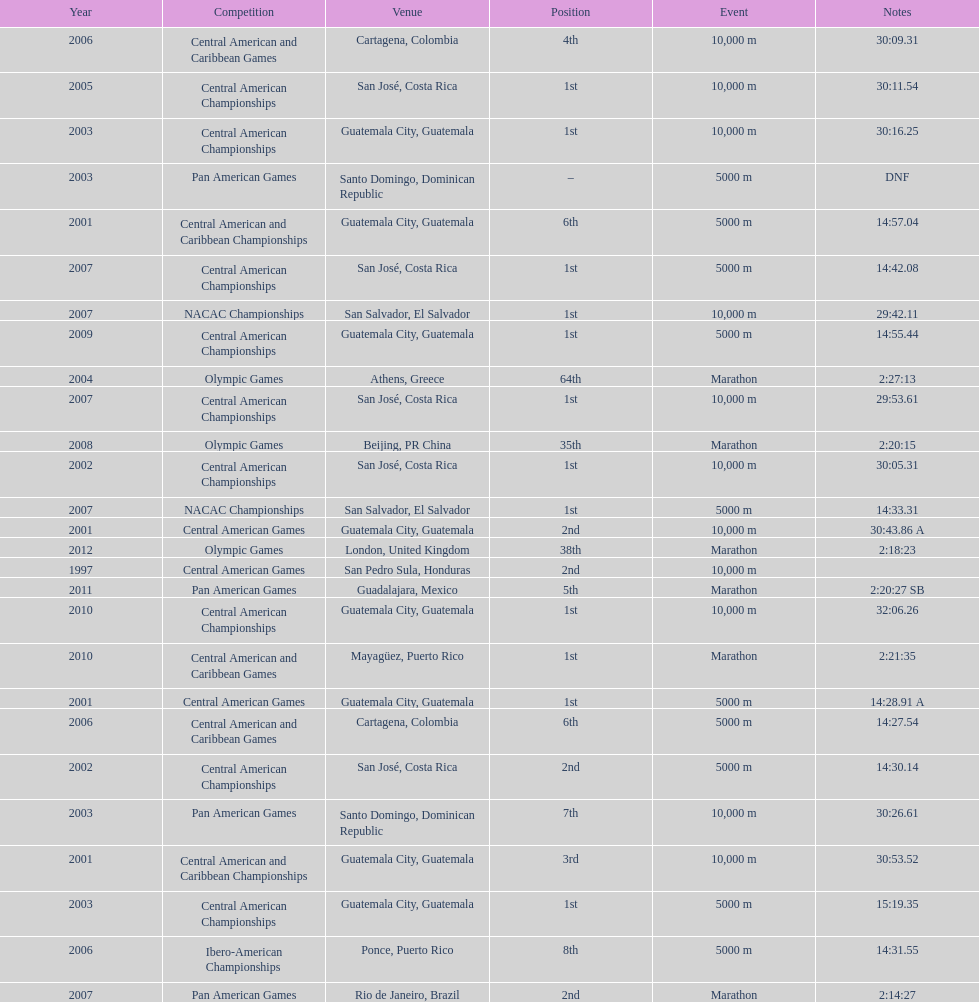Help me parse the entirety of this table. {'header': ['Year', 'Competition', 'Venue', 'Position', 'Event', 'Notes'], 'rows': [['2006', 'Central American and Caribbean Games', 'Cartagena, Colombia', '4th', '10,000 m', '30:09.31'], ['2005', 'Central American Championships', 'San José, Costa Rica', '1st', '10,000 m', '30:11.54'], ['2003', 'Central American Championships', 'Guatemala City, Guatemala', '1st', '10,000 m', '30:16.25'], ['2003', 'Pan American Games', 'Santo Domingo, Dominican Republic', '–', '5000 m', 'DNF'], ['2001', 'Central American and Caribbean Championships', 'Guatemala City, Guatemala', '6th', '5000 m', '14:57.04'], ['2007', 'Central American Championships', 'San José, Costa Rica', '1st', '5000 m', '14:42.08'], ['2007', 'NACAC Championships', 'San Salvador, El Salvador', '1st', '10,000 m', '29:42.11'], ['2009', 'Central American Championships', 'Guatemala City, Guatemala', '1st', '5000 m', '14:55.44'], ['2004', 'Olympic Games', 'Athens, Greece', '64th', 'Marathon', '2:27:13'], ['2007', 'Central American Championships', 'San José, Costa Rica', '1st', '10,000 m', '29:53.61'], ['2008', 'Olympic Games', 'Beijing, PR China', '35th', 'Marathon', '2:20:15'], ['2002', 'Central American Championships', 'San José, Costa Rica', '1st', '10,000 m', '30:05.31'], ['2007', 'NACAC Championships', 'San Salvador, El Salvador', '1st', '5000 m', '14:33.31'], ['2001', 'Central American Games', 'Guatemala City, Guatemala', '2nd', '10,000 m', '30:43.86 A'], ['2012', 'Olympic Games', 'London, United Kingdom', '38th', 'Marathon', '2:18:23'], ['1997', 'Central American Games', 'San Pedro Sula, Honduras', '2nd', '10,000 m', ''], ['2011', 'Pan American Games', 'Guadalajara, Mexico', '5th', 'Marathon', '2:20:27 SB'], ['2010', 'Central American Championships', 'Guatemala City, Guatemala', '1st', '10,000 m', '32:06.26'], ['2010', 'Central American and Caribbean Games', 'Mayagüez, Puerto Rico', '1st', 'Marathon', '2:21:35'], ['2001', 'Central American Games', 'Guatemala City, Guatemala', '1st', '5000 m', '14:28.91 A'], ['2006', 'Central American and Caribbean Games', 'Cartagena, Colombia', '6th', '5000 m', '14:27.54'], ['2002', 'Central American Championships', 'San José, Costa Rica', '2nd', '5000 m', '14:30.14'], ['2003', 'Pan American Games', 'Santo Domingo, Dominican Republic', '7th', '10,000 m', '30:26.61'], ['2001', 'Central American and Caribbean Championships', 'Guatemala City, Guatemala', '3rd', '10,000 m', '30:53.52'], ['2003', 'Central American Championships', 'Guatemala City, Guatemala', '1st', '5000 m', '15:19.35'], ['2006', 'Ibero-American Championships', 'Ponce, Puerto Rico', '8th', '5000 m', '14:31.55'], ['2007', 'Pan American Games', 'Rio de Janeiro, Brazil', '2nd', 'Marathon', '2:14:27']]} The central american championships and what other tournament happened in 2010? Central American and Caribbean Games. 